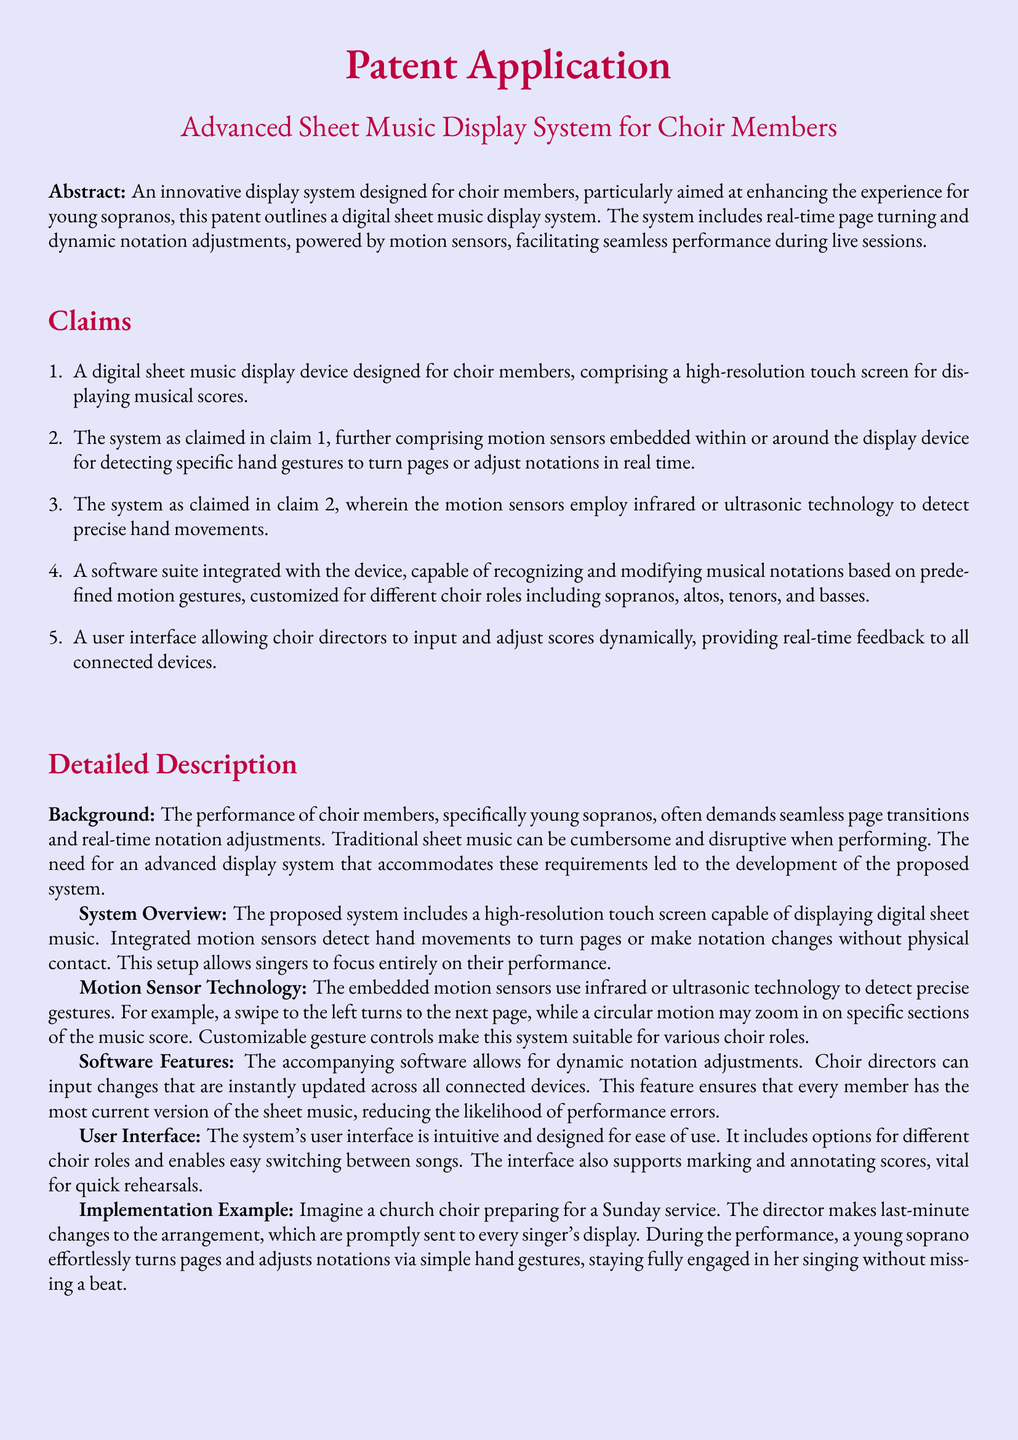What is the title of the patent application? The title of the patent application is stated at the beginning of the document, specifying the focus on a display system for choir members.
Answer: Advanced Sheet Music Display System for Choir Members What technology do the motion sensors employ? The motion sensors use a specific type of technology for detecting hand movements, as explained in the section on motion sensor technology.
Answer: Infrared or ultrasonic technology How many claims are listed in the document? The number of claims is indicated in the claims section, counting each item.
Answer: Five What allows choir directors to input changes in the system? The feature allowing choir directors to make adjustments in real-time is described under software features, detailing its function.
Answer: A software suite What is the intended primary audience of the system? The intended primary audience is reflected in the background section, indicating the specific group the system aims to support.
Answer: Young sopranos What type of interface is designed for ease of use? The user interface type is highlighted in the document, emphasizing its design purpose for users.
Answer: Intuitive What example is given to illustrate the system's implementation? An example included in the detailed description section illustrates how the system would work in practice.
Answer: Church choir preparing for a Sunday service What does the diagram in the drawings illustrate? The diagram is mentioned in the drawings section, indicating its purpose in showcasing the system's components.
Answer: The digital sheet music display system 